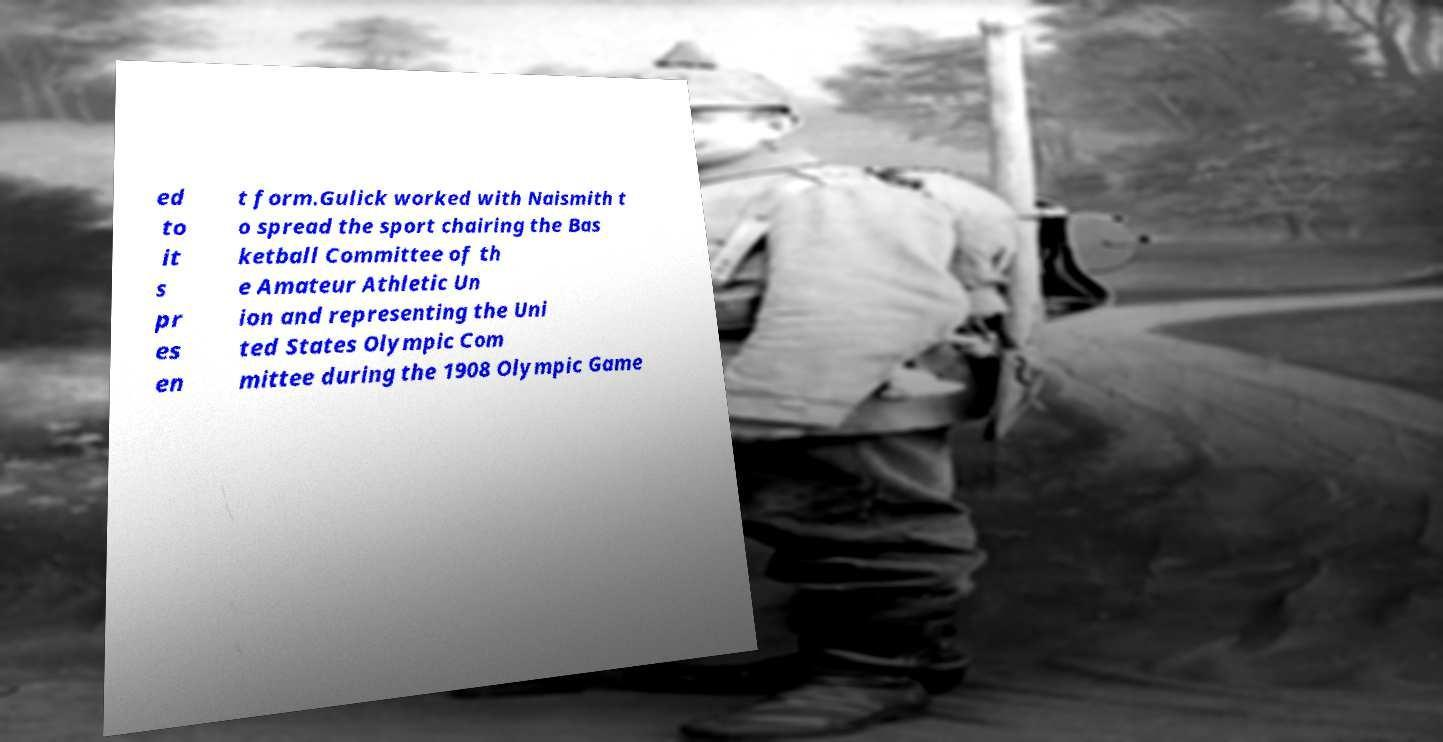For documentation purposes, I need the text within this image transcribed. Could you provide that? ed to it s pr es en t form.Gulick worked with Naismith t o spread the sport chairing the Bas ketball Committee of th e Amateur Athletic Un ion and representing the Uni ted States Olympic Com mittee during the 1908 Olympic Game 